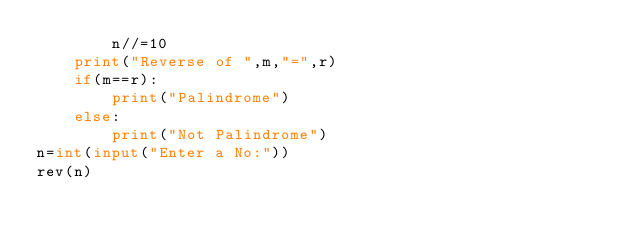Convert code to text. <code><loc_0><loc_0><loc_500><loc_500><_Python_>        n//=10
    print("Reverse of ",m,"=",r)
    if(m==r):
        print("Palindrome")
    else:
        print("Not Palindrome")
n=int(input("Enter a No:"))
rev(n)</code> 